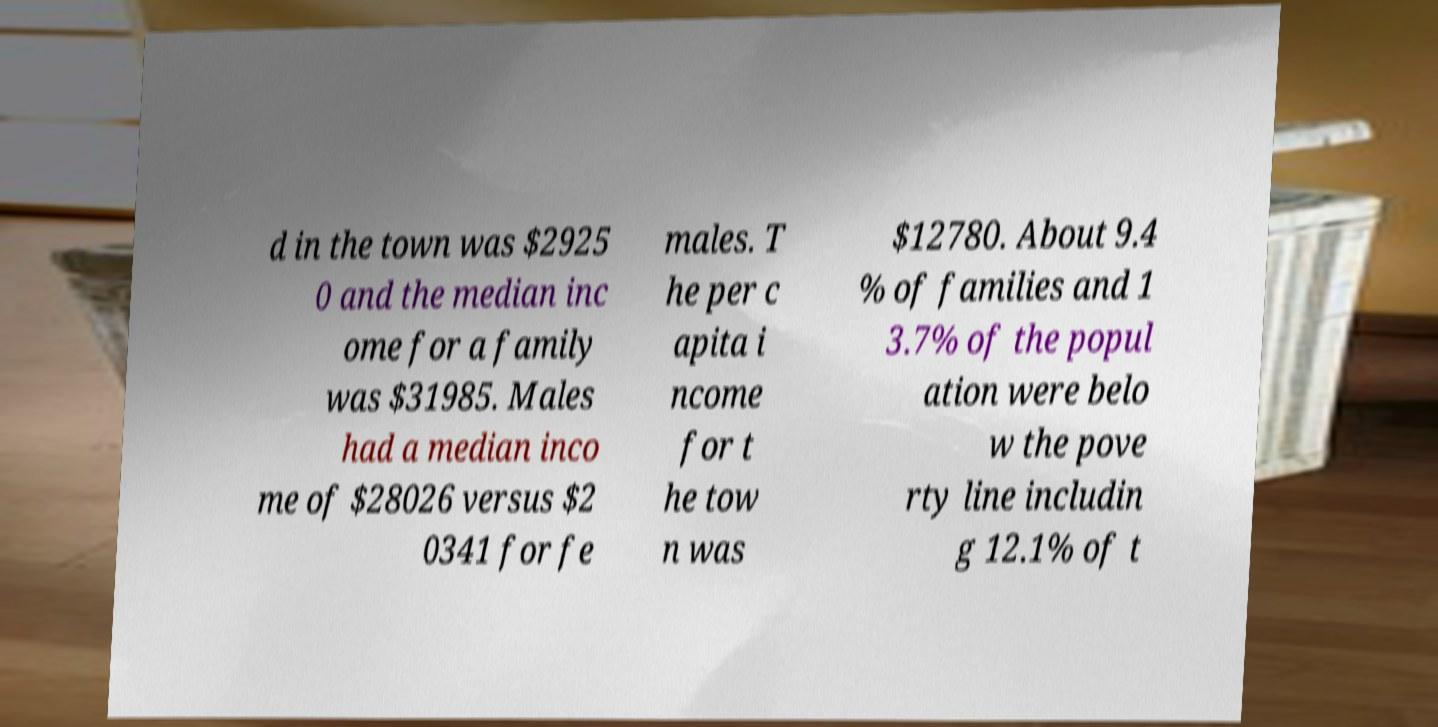Please read and relay the text visible in this image. What does it say? d in the town was $2925 0 and the median inc ome for a family was $31985. Males had a median inco me of $28026 versus $2 0341 for fe males. T he per c apita i ncome for t he tow n was $12780. About 9.4 % of families and 1 3.7% of the popul ation were belo w the pove rty line includin g 12.1% of t 